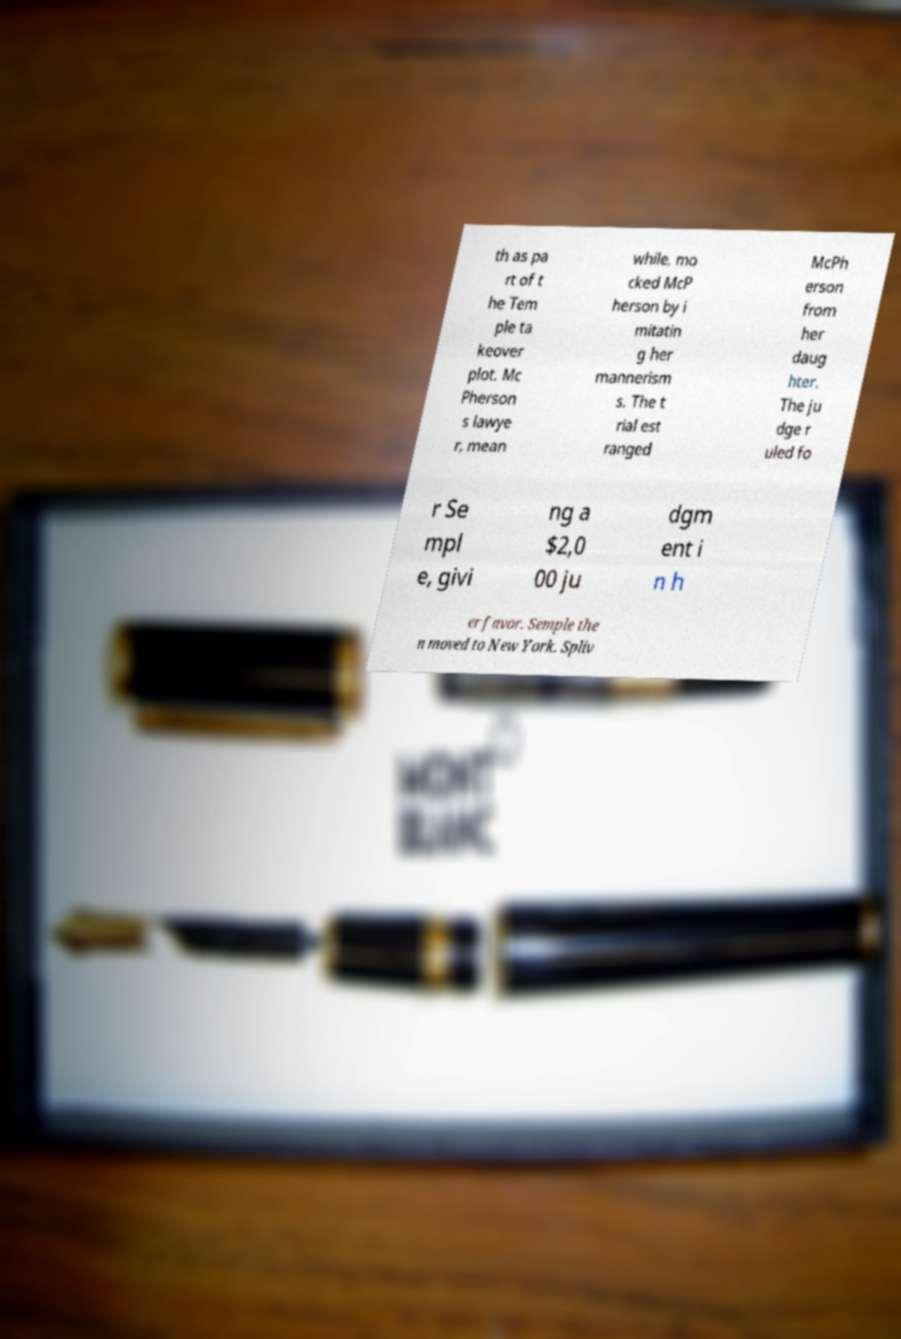Please identify and transcribe the text found in this image. th as pa rt of t he Tem ple ta keover plot. Mc Pherson s lawye r, mean while, mo cked McP herson by i mitatin g her mannerism s. The t rial est ranged McPh erson from her daug hter. The ju dge r uled fo r Se mpl e, givi ng a $2,0 00 ju dgm ent i n h er favor. Semple the n moved to New York. Spliv 